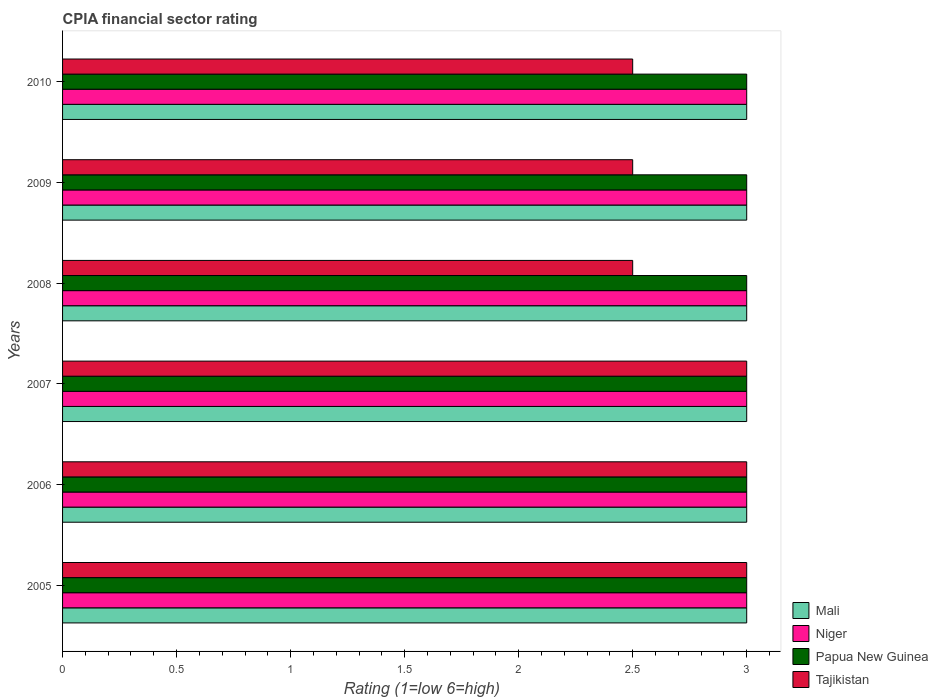Are the number of bars on each tick of the Y-axis equal?
Offer a very short reply. Yes. How many bars are there on the 4th tick from the top?
Provide a succinct answer. 4. How many bars are there on the 1st tick from the bottom?
Offer a very short reply. 4. What is the label of the 2nd group of bars from the top?
Give a very brief answer. 2009. Across all years, what is the maximum CPIA rating in Mali?
Your answer should be compact. 3. Across all years, what is the minimum CPIA rating in Papua New Guinea?
Provide a succinct answer. 3. In which year was the CPIA rating in Papua New Guinea maximum?
Provide a short and direct response. 2005. In which year was the CPIA rating in Tajikistan minimum?
Your response must be concise. 2008. What is the total CPIA rating in Mali in the graph?
Offer a terse response. 18. In how many years, is the CPIA rating in Mali greater than 2.4 ?
Ensure brevity in your answer.  6. What is the ratio of the CPIA rating in Mali in 2006 to that in 2007?
Provide a succinct answer. 1. Is the difference between the CPIA rating in Niger in 2006 and 2008 greater than the difference between the CPIA rating in Papua New Guinea in 2006 and 2008?
Offer a very short reply. No. What is the difference between the highest and the lowest CPIA rating in Niger?
Keep it short and to the point. 0. In how many years, is the CPIA rating in Papua New Guinea greater than the average CPIA rating in Papua New Guinea taken over all years?
Your answer should be very brief. 0. Is the sum of the CPIA rating in Niger in 2009 and 2010 greater than the maximum CPIA rating in Tajikistan across all years?
Your response must be concise. Yes. Is it the case that in every year, the sum of the CPIA rating in Mali and CPIA rating in Papua New Guinea is greater than the sum of CPIA rating in Niger and CPIA rating in Tajikistan?
Ensure brevity in your answer.  No. What does the 2nd bar from the top in 2005 represents?
Ensure brevity in your answer.  Papua New Guinea. What does the 1st bar from the bottom in 2010 represents?
Offer a very short reply. Mali. Are all the bars in the graph horizontal?
Your response must be concise. Yes. Are the values on the major ticks of X-axis written in scientific E-notation?
Your response must be concise. No. How many legend labels are there?
Give a very brief answer. 4. What is the title of the graph?
Provide a succinct answer. CPIA financial sector rating. Does "Egypt, Arab Rep." appear as one of the legend labels in the graph?
Your answer should be very brief. No. What is the label or title of the X-axis?
Provide a succinct answer. Rating (1=low 6=high). What is the Rating (1=low 6=high) in Mali in 2005?
Make the answer very short. 3. What is the Rating (1=low 6=high) in Papua New Guinea in 2005?
Your answer should be compact. 3. What is the Rating (1=low 6=high) of Tajikistan in 2005?
Offer a terse response. 3. What is the Rating (1=low 6=high) in Niger in 2006?
Provide a short and direct response. 3. What is the Rating (1=low 6=high) in Papua New Guinea in 2006?
Your response must be concise. 3. What is the Rating (1=low 6=high) of Mali in 2007?
Provide a short and direct response. 3. What is the Rating (1=low 6=high) of Tajikistan in 2007?
Offer a very short reply. 3. What is the Rating (1=low 6=high) in Papua New Guinea in 2008?
Your answer should be compact. 3. What is the Rating (1=low 6=high) in Tajikistan in 2008?
Offer a terse response. 2.5. What is the Rating (1=low 6=high) in Mali in 2009?
Make the answer very short. 3. What is the Rating (1=low 6=high) of Papua New Guinea in 2009?
Offer a very short reply. 3. What is the Rating (1=low 6=high) in Niger in 2010?
Offer a very short reply. 3. Across all years, what is the minimum Rating (1=low 6=high) in Mali?
Your response must be concise. 3. Across all years, what is the minimum Rating (1=low 6=high) of Papua New Guinea?
Give a very brief answer. 3. Across all years, what is the minimum Rating (1=low 6=high) of Tajikistan?
Ensure brevity in your answer.  2.5. What is the total Rating (1=low 6=high) in Papua New Guinea in the graph?
Ensure brevity in your answer.  18. What is the total Rating (1=low 6=high) in Tajikistan in the graph?
Your answer should be very brief. 16.5. What is the difference between the Rating (1=low 6=high) of Mali in 2005 and that in 2006?
Offer a very short reply. 0. What is the difference between the Rating (1=low 6=high) of Niger in 2005 and that in 2006?
Your answer should be very brief. 0. What is the difference between the Rating (1=low 6=high) of Tajikistan in 2005 and that in 2006?
Your response must be concise. 0. What is the difference between the Rating (1=low 6=high) in Mali in 2005 and that in 2007?
Give a very brief answer. 0. What is the difference between the Rating (1=low 6=high) of Tajikistan in 2005 and that in 2007?
Your answer should be compact. 0. What is the difference between the Rating (1=low 6=high) of Mali in 2005 and that in 2008?
Make the answer very short. 0. What is the difference between the Rating (1=low 6=high) of Papua New Guinea in 2005 and that in 2008?
Provide a succinct answer. 0. What is the difference between the Rating (1=low 6=high) in Tajikistan in 2005 and that in 2008?
Keep it short and to the point. 0.5. What is the difference between the Rating (1=low 6=high) of Mali in 2005 and that in 2009?
Your answer should be compact. 0. What is the difference between the Rating (1=low 6=high) in Niger in 2005 and that in 2009?
Provide a short and direct response. 0. What is the difference between the Rating (1=low 6=high) of Papua New Guinea in 2005 and that in 2009?
Make the answer very short. 0. What is the difference between the Rating (1=low 6=high) of Tajikistan in 2005 and that in 2009?
Offer a terse response. 0.5. What is the difference between the Rating (1=low 6=high) of Niger in 2006 and that in 2007?
Ensure brevity in your answer.  0. What is the difference between the Rating (1=low 6=high) in Tajikistan in 2006 and that in 2007?
Provide a succinct answer. 0. What is the difference between the Rating (1=low 6=high) of Mali in 2006 and that in 2008?
Ensure brevity in your answer.  0. What is the difference between the Rating (1=low 6=high) in Niger in 2006 and that in 2008?
Make the answer very short. 0. What is the difference between the Rating (1=low 6=high) of Papua New Guinea in 2006 and that in 2008?
Make the answer very short. 0. What is the difference between the Rating (1=low 6=high) of Tajikistan in 2006 and that in 2008?
Ensure brevity in your answer.  0.5. What is the difference between the Rating (1=low 6=high) of Niger in 2006 and that in 2009?
Keep it short and to the point. 0. What is the difference between the Rating (1=low 6=high) in Tajikistan in 2006 and that in 2009?
Offer a terse response. 0.5. What is the difference between the Rating (1=low 6=high) in Mali in 2006 and that in 2010?
Keep it short and to the point. 0. What is the difference between the Rating (1=low 6=high) of Tajikistan in 2006 and that in 2010?
Provide a short and direct response. 0.5. What is the difference between the Rating (1=low 6=high) of Mali in 2007 and that in 2008?
Make the answer very short. 0. What is the difference between the Rating (1=low 6=high) of Niger in 2007 and that in 2008?
Offer a very short reply. 0. What is the difference between the Rating (1=low 6=high) of Papua New Guinea in 2007 and that in 2008?
Your answer should be very brief. 0. What is the difference between the Rating (1=low 6=high) of Tajikistan in 2007 and that in 2008?
Your answer should be compact. 0.5. What is the difference between the Rating (1=low 6=high) of Mali in 2007 and that in 2009?
Ensure brevity in your answer.  0. What is the difference between the Rating (1=low 6=high) of Niger in 2007 and that in 2009?
Your answer should be compact. 0. What is the difference between the Rating (1=low 6=high) of Tajikistan in 2007 and that in 2010?
Provide a succinct answer. 0.5. What is the difference between the Rating (1=low 6=high) of Niger in 2008 and that in 2009?
Ensure brevity in your answer.  0. What is the difference between the Rating (1=low 6=high) of Papua New Guinea in 2008 and that in 2009?
Keep it short and to the point. 0. What is the difference between the Rating (1=low 6=high) of Tajikistan in 2008 and that in 2009?
Give a very brief answer. 0. What is the difference between the Rating (1=low 6=high) of Mali in 2008 and that in 2010?
Your response must be concise. 0. What is the difference between the Rating (1=low 6=high) of Papua New Guinea in 2008 and that in 2010?
Your answer should be compact. 0. What is the difference between the Rating (1=low 6=high) of Tajikistan in 2008 and that in 2010?
Your answer should be compact. 0. What is the difference between the Rating (1=low 6=high) in Tajikistan in 2009 and that in 2010?
Keep it short and to the point. 0. What is the difference between the Rating (1=low 6=high) of Mali in 2005 and the Rating (1=low 6=high) of Niger in 2006?
Your answer should be compact. 0. What is the difference between the Rating (1=low 6=high) of Niger in 2005 and the Rating (1=low 6=high) of Papua New Guinea in 2006?
Provide a succinct answer. 0. What is the difference between the Rating (1=low 6=high) in Mali in 2005 and the Rating (1=low 6=high) in Tajikistan in 2007?
Ensure brevity in your answer.  0. What is the difference between the Rating (1=low 6=high) in Niger in 2005 and the Rating (1=low 6=high) in Papua New Guinea in 2007?
Offer a very short reply. 0. What is the difference between the Rating (1=low 6=high) of Papua New Guinea in 2005 and the Rating (1=low 6=high) of Tajikistan in 2007?
Offer a terse response. 0. What is the difference between the Rating (1=low 6=high) in Niger in 2005 and the Rating (1=low 6=high) in Papua New Guinea in 2009?
Your answer should be compact. 0. What is the difference between the Rating (1=low 6=high) of Papua New Guinea in 2005 and the Rating (1=low 6=high) of Tajikistan in 2009?
Your answer should be compact. 0.5. What is the difference between the Rating (1=low 6=high) in Mali in 2005 and the Rating (1=low 6=high) in Tajikistan in 2010?
Give a very brief answer. 0.5. What is the difference between the Rating (1=low 6=high) in Niger in 2005 and the Rating (1=low 6=high) in Papua New Guinea in 2010?
Make the answer very short. 0. What is the difference between the Rating (1=low 6=high) in Mali in 2006 and the Rating (1=low 6=high) in Niger in 2007?
Provide a short and direct response. 0. What is the difference between the Rating (1=low 6=high) in Mali in 2006 and the Rating (1=low 6=high) in Tajikistan in 2007?
Offer a very short reply. 0. What is the difference between the Rating (1=low 6=high) of Niger in 2006 and the Rating (1=low 6=high) of Papua New Guinea in 2007?
Offer a terse response. 0. What is the difference between the Rating (1=low 6=high) in Niger in 2006 and the Rating (1=low 6=high) in Tajikistan in 2007?
Your answer should be compact. 0. What is the difference between the Rating (1=low 6=high) of Papua New Guinea in 2006 and the Rating (1=low 6=high) of Tajikistan in 2007?
Ensure brevity in your answer.  0. What is the difference between the Rating (1=low 6=high) of Mali in 2006 and the Rating (1=low 6=high) of Papua New Guinea in 2008?
Ensure brevity in your answer.  0. What is the difference between the Rating (1=low 6=high) in Niger in 2006 and the Rating (1=low 6=high) in Papua New Guinea in 2008?
Ensure brevity in your answer.  0. What is the difference between the Rating (1=low 6=high) in Papua New Guinea in 2006 and the Rating (1=low 6=high) in Tajikistan in 2008?
Your response must be concise. 0.5. What is the difference between the Rating (1=low 6=high) of Mali in 2006 and the Rating (1=low 6=high) of Niger in 2009?
Keep it short and to the point. 0. What is the difference between the Rating (1=low 6=high) of Mali in 2006 and the Rating (1=low 6=high) of Papua New Guinea in 2009?
Offer a terse response. 0. What is the difference between the Rating (1=low 6=high) of Niger in 2006 and the Rating (1=low 6=high) of Papua New Guinea in 2009?
Your answer should be very brief. 0. What is the difference between the Rating (1=low 6=high) of Mali in 2006 and the Rating (1=low 6=high) of Niger in 2010?
Keep it short and to the point. 0. What is the difference between the Rating (1=low 6=high) in Mali in 2006 and the Rating (1=low 6=high) in Papua New Guinea in 2010?
Provide a succinct answer. 0. What is the difference between the Rating (1=low 6=high) of Mali in 2006 and the Rating (1=low 6=high) of Tajikistan in 2010?
Ensure brevity in your answer.  0.5. What is the difference between the Rating (1=low 6=high) of Papua New Guinea in 2006 and the Rating (1=low 6=high) of Tajikistan in 2010?
Keep it short and to the point. 0.5. What is the difference between the Rating (1=low 6=high) in Mali in 2007 and the Rating (1=low 6=high) in Papua New Guinea in 2008?
Provide a succinct answer. 0. What is the difference between the Rating (1=low 6=high) of Mali in 2007 and the Rating (1=low 6=high) of Tajikistan in 2008?
Make the answer very short. 0.5. What is the difference between the Rating (1=low 6=high) in Niger in 2007 and the Rating (1=low 6=high) in Tajikistan in 2008?
Make the answer very short. 0.5. What is the difference between the Rating (1=low 6=high) of Papua New Guinea in 2007 and the Rating (1=low 6=high) of Tajikistan in 2008?
Offer a very short reply. 0.5. What is the difference between the Rating (1=low 6=high) in Mali in 2007 and the Rating (1=low 6=high) in Niger in 2009?
Make the answer very short. 0. What is the difference between the Rating (1=low 6=high) of Mali in 2007 and the Rating (1=low 6=high) of Papua New Guinea in 2009?
Offer a very short reply. 0. What is the difference between the Rating (1=low 6=high) in Mali in 2007 and the Rating (1=low 6=high) in Tajikistan in 2009?
Make the answer very short. 0.5. What is the difference between the Rating (1=low 6=high) of Niger in 2007 and the Rating (1=low 6=high) of Papua New Guinea in 2009?
Your response must be concise. 0. What is the difference between the Rating (1=low 6=high) in Niger in 2007 and the Rating (1=low 6=high) in Tajikistan in 2009?
Keep it short and to the point. 0.5. What is the difference between the Rating (1=low 6=high) in Mali in 2007 and the Rating (1=low 6=high) in Niger in 2010?
Keep it short and to the point. 0. What is the difference between the Rating (1=low 6=high) of Niger in 2007 and the Rating (1=low 6=high) of Papua New Guinea in 2010?
Your answer should be very brief. 0. What is the difference between the Rating (1=low 6=high) in Niger in 2007 and the Rating (1=low 6=high) in Tajikistan in 2010?
Provide a succinct answer. 0.5. What is the difference between the Rating (1=low 6=high) in Mali in 2008 and the Rating (1=low 6=high) in Tajikistan in 2009?
Provide a short and direct response. 0.5. What is the difference between the Rating (1=low 6=high) in Niger in 2008 and the Rating (1=low 6=high) in Papua New Guinea in 2009?
Give a very brief answer. 0. What is the difference between the Rating (1=low 6=high) in Mali in 2008 and the Rating (1=low 6=high) in Niger in 2010?
Your response must be concise. 0. What is the difference between the Rating (1=low 6=high) in Mali in 2008 and the Rating (1=low 6=high) in Tajikistan in 2010?
Keep it short and to the point. 0.5. What is the difference between the Rating (1=low 6=high) in Niger in 2008 and the Rating (1=low 6=high) in Papua New Guinea in 2010?
Make the answer very short. 0. What is the difference between the Rating (1=low 6=high) in Papua New Guinea in 2008 and the Rating (1=low 6=high) in Tajikistan in 2010?
Keep it short and to the point. 0.5. What is the difference between the Rating (1=low 6=high) in Mali in 2009 and the Rating (1=low 6=high) in Papua New Guinea in 2010?
Offer a terse response. 0. What is the difference between the Rating (1=low 6=high) in Mali in 2009 and the Rating (1=low 6=high) in Tajikistan in 2010?
Provide a short and direct response. 0.5. What is the difference between the Rating (1=low 6=high) of Niger in 2009 and the Rating (1=low 6=high) of Papua New Guinea in 2010?
Keep it short and to the point. 0. What is the average Rating (1=low 6=high) of Papua New Guinea per year?
Provide a short and direct response. 3. What is the average Rating (1=low 6=high) in Tajikistan per year?
Provide a short and direct response. 2.75. In the year 2005, what is the difference between the Rating (1=low 6=high) in Mali and Rating (1=low 6=high) in Niger?
Your response must be concise. 0. In the year 2005, what is the difference between the Rating (1=low 6=high) of Niger and Rating (1=low 6=high) of Papua New Guinea?
Your answer should be compact. 0. In the year 2006, what is the difference between the Rating (1=low 6=high) in Mali and Rating (1=low 6=high) in Niger?
Provide a succinct answer. 0. In the year 2006, what is the difference between the Rating (1=low 6=high) in Mali and Rating (1=low 6=high) in Papua New Guinea?
Keep it short and to the point. 0. In the year 2006, what is the difference between the Rating (1=low 6=high) in Mali and Rating (1=low 6=high) in Tajikistan?
Offer a very short reply. 0. In the year 2007, what is the difference between the Rating (1=low 6=high) of Mali and Rating (1=low 6=high) of Niger?
Give a very brief answer. 0. In the year 2007, what is the difference between the Rating (1=low 6=high) in Niger and Rating (1=low 6=high) in Papua New Guinea?
Your answer should be compact. 0. In the year 2007, what is the difference between the Rating (1=low 6=high) of Niger and Rating (1=low 6=high) of Tajikistan?
Keep it short and to the point. 0. In the year 2007, what is the difference between the Rating (1=low 6=high) of Papua New Guinea and Rating (1=low 6=high) of Tajikistan?
Your answer should be compact. 0. In the year 2008, what is the difference between the Rating (1=low 6=high) in Mali and Rating (1=low 6=high) in Tajikistan?
Offer a terse response. 0.5. In the year 2008, what is the difference between the Rating (1=low 6=high) of Niger and Rating (1=low 6=high) of Papua New Guinea?
Ensure brevity in your answer.  0. In the year 2009, what is the difference between the Rating (1=low 6=high) in Mali and Rating (1=low 6=high) in Niger?
Give a very brief answer. 0. In the year 2009, what is the difference between the Rating (1=low 6=high) of Mali and Rating (1=low 6=high) of Papua New Guinea?
Offer a very short reply. 0. What is the ratio of the Rating (1=low 6=high) in Tajikistan in 2005 to that in 2006?
Your response must be concise. 1. What is the ratio of the Rating (1=low 6=high) of Mali in 2005 to that in 2007?
Provide a short and direct response. 1. What is the ratio of the Rating (1=low 6=high) in Papua New Guinea in 2005 to that in 2007?
Offer a terse response. 1. What is the ratio of the Rating (1=low 6=high) of Tajikistan in 2005 to that in 2007?
Keep it short and to the point. 1. What is the ratio of the Rating (1=low 6=high) of Papua New Guinea in 2005 to that in 2008?
Your answer should be compact. 1. What is the ratio of the Rating (1=low 6=high) in Mali in 2005 to that in 2009?
Your answer should be very brief. 1. What is the ratio of the Rating (1=low 6=high) in Papua New Guinea in 2005 to that in 2009?
Offer a terse response. 1. What is the ratio of the Rating (1=low 6=high) in Mali in 2005 to that in 2010?
Make the answer very short. 1. What is the ratio of the Rating (1=low 6=high) in Papua New Guinea in 2005 to that in 2010?
Provide a succinct answer. 1. What is the ratio of the Rating (1=low 6=high) of Mali in 2006 to that in 2008?
Give a very brief answer. 1. What is the ratio of the Rating (1=low 6=high) in Papua New Guinea in 2006 to that in 2008?
Your response must be concise. 1. What is the ratio of the Rating (1=low 6=high) of Tajikistan in 2006 to that in 2008?
Make the answer very short. 1.2. What is the ratio of the Rating (1=low 6=high) in Mali in 2006 to that in 2009?
Offer a terse response. 1. What is the ratio of the Rating (1=low 6=high) in Niger in 2006 to that in 2009?
Make the answer very short. 1. What is the ratio of the Rating (1=low 6=high) of Papua New Guinea in 2006 to that in 2009?
Offer a very short reply. 1. What is the ratio of the Rating (1=low 6=high) in Niger in 2006 to that in 2010?
Give a very brief answer. 1. What is the ratio of the Rating (1=low 6=high) of Tajikistan in 2006 to that in 2010?
Offer a terse response. 1.2. What is the ratio of the Rating (1=low 6=high) in Mali in 2007 to that in 2008?
Offer a very short reply. 1. What is the ratio of the Rating (1=low 6=high) of Papua New Guinea in 2007 to that in 2008?
Provide a short and direct response. 1. What is the ratio of the Rating (1=low 6=high) of Mali in 2007 to that in 2009?
Your answer should be compact. 1. What is the ratio of the Rating (1=low 6=high) of Mali in 2007 to that in 2010?
Give a very brief answer. 1. What is the ratio of the Rating (1=low 6=high) of Tajikistan in 2007 to that in 2010?
Provide a short and direct response. 1.2. What is the ratio of the Rating (1=low 6=high) in Niger in 2008 to that in 2009?
Your answer should be very brief. 1. What is the ratio of the Rating (1=low 6=high) in Tajikistan in 2008 to that in 2009?
Your answer should be very brief. 1. What is the ratio of the Rating (1=low 6=high) in Mali in 2008 to that in 2010?
Ensure brevity in your answer.  1. What is the ratio of the Rating (1=low 6=high) in Papua New Guinea in 2009 to that in 2010?
Keep it short and to the point. 1. What is the difference between the highest and the second highest Rating (1=low 6=high) in Mali?
Offer a very short reply. 0. What is the difference between the highest and the second highest Rating (1=low 6=high) of Niger?
Ensure brevity in your answer.  0. What is the difference between the highest and the second highest Rating (1=low 6=high) in Papua New Guinea?
Ensure brevity in your answer.  0. What is the difference between the highest and the second highest Rating (1=low 6=high) in Tajikistan?
Make the answer very short. 0. What is the difference between the highest and the lowest Rating (1=low 6=high) of Mali?
Keep it short and to the point. 0. What is the difference between the highest and the lowest Rating (1=low 6=high) of Niger?
Ensure brevity in your answer.  0. What is the difference between the highest and the lowest Rating (1=low 6=high) in Tajikistan?
Provide a short and direct response. 0.5. 